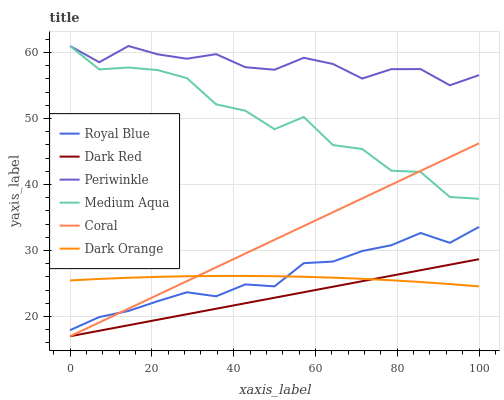Does Coral have the minimum area under the curve?
Answer yes or no. No. Does Coral have the maximum area under the curve?
Answer yes or no. No. Is Dark Red the smoothest?
Answer yes or no. No. Is Dark Red the roughest?
Answer yes or no. No. Does Royal Blue have the lowest value?
Answer yes or no. No. Does Dark Red have the highest value?
Answer yes or no. No. Is Coral less than Periwinkle?
Answer yes or no. Yes. Is Periwinkle greater than Coral?
Answer yes or no. Yes. Does Coral intersect Periwinkle?
Answer yes or no. No. 